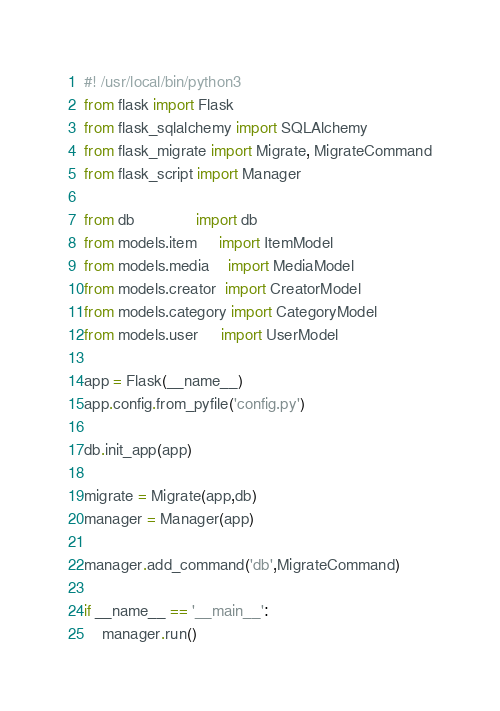<code> <loc_0><loc_0><loc_500><loc_500><_Python_>#! /usr/local/bin/python3 
from flask import Flask
from flask_sqlalchemy import SQLAlchemy
from flask_migrate import Migrate, MigrateCommand
from flask_script import Manager

from db              import db
from models.item     import ItemModel
from models.media    import MediaModel   
from models.creator  import CreatorModel
from models.category import CategoryModel
from models.user     import UserModel

app = Flask(__name__)
app.config.from_pyfile('config.py')

db.init_app(app)

migrate = Migrate(app,db)
manager = Manager(app)

manager.add_command('db',MigrateCommand)

if __name__ == '__main__':
    manager.run()</code> 